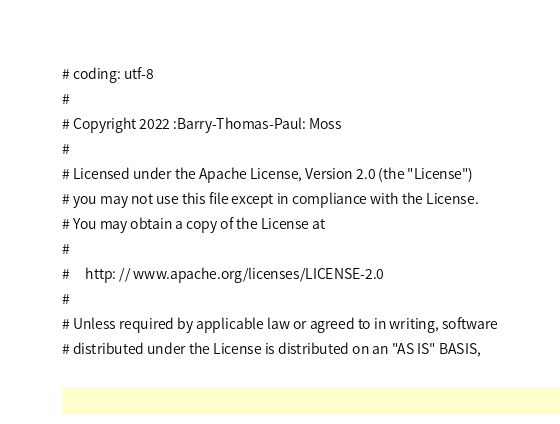<code> <loc_0><loc_0><loc_500><loc_500><_Python_># coding: utf-8
#
# Copyright 2022 :Barry-Thomas-Paul: Moss
#
# Licensed under the Apache License, Version 2.0 (the "License")
# you may not use this file except in compliance with the License.
# You may obtain a copy of the License at
#
#     http: // www.apache.org/licenses/LICENSE-2.0
#
# Unless required by applicable law or agreed to in writing, software
# distributed under the License is distributed on an "AS IS" BASIS,</code> 